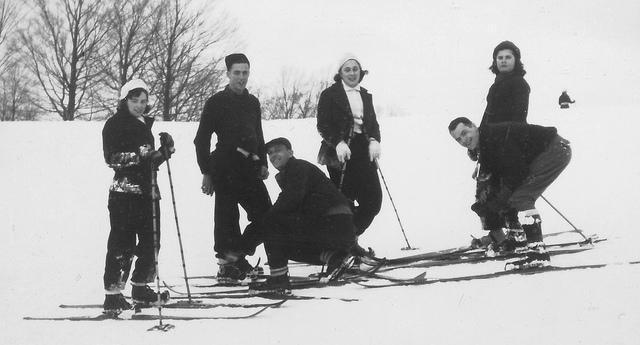How many of the women are wearing hats?
Give a very brief answer. 2. How many people can be seen?
Give a very brief answer. 6. How many ovens in this image have a window on their door?
Give a very brief answer. 0. 